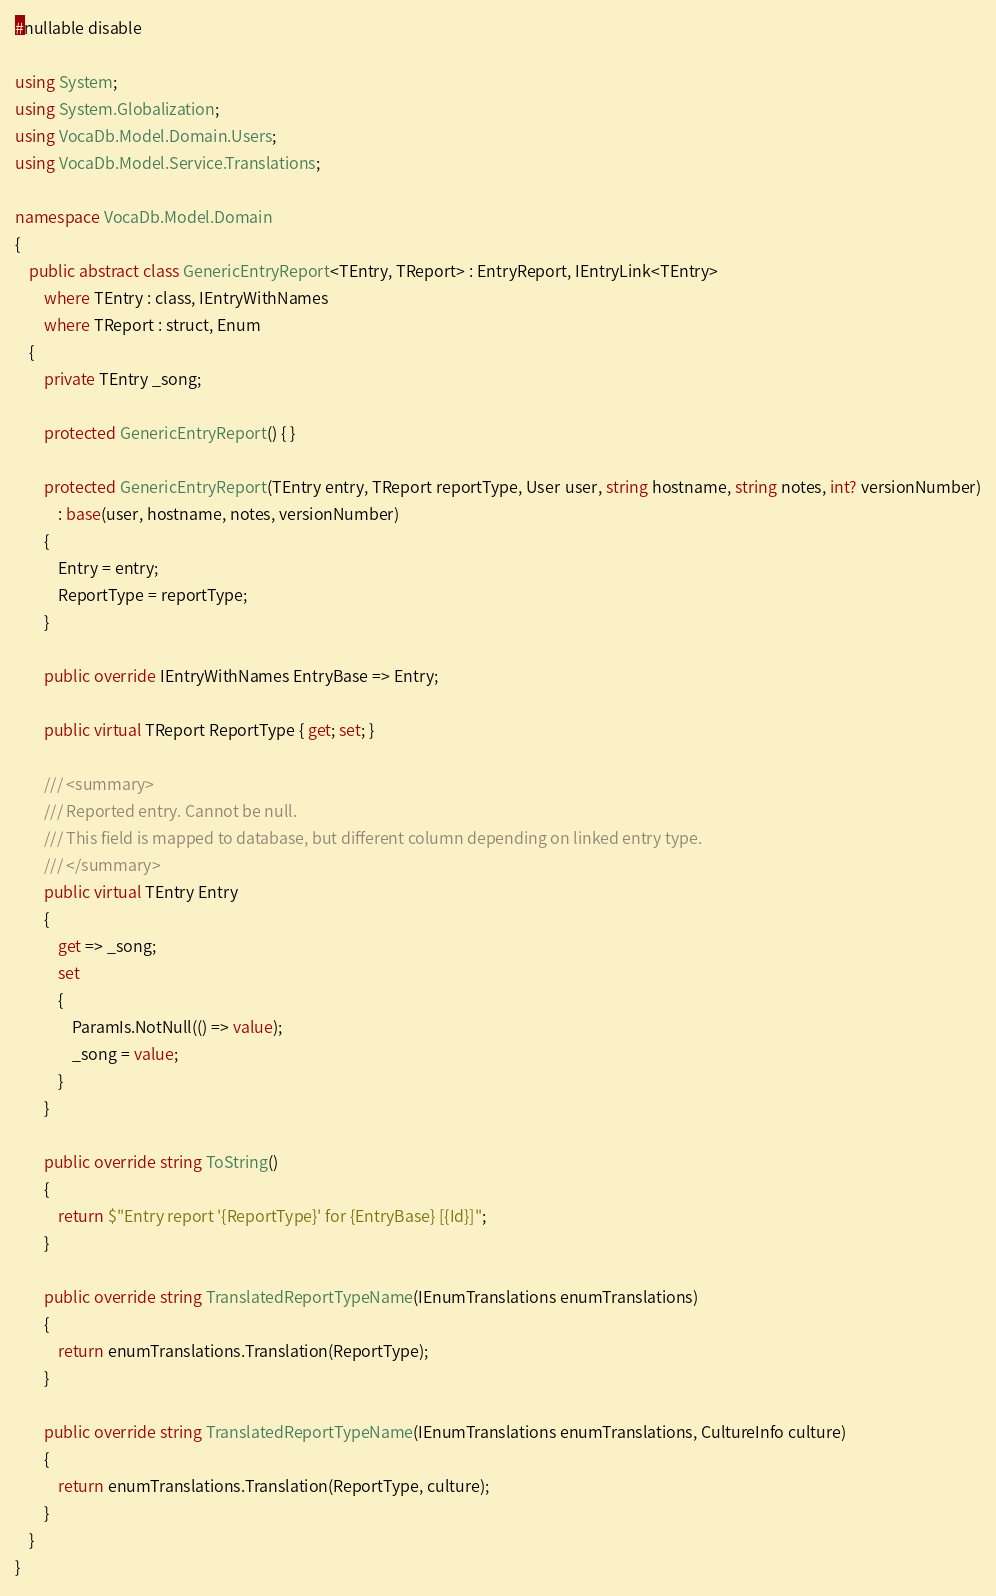Convert code to text. <code><loc_0><loc_0><loc_500><loc_500><_C#_>#nullable disable

using System;
using System.Globalization;
using VocaDb.Model.Domain.Users;
using VocaDb.Model.Service.Translations;

namespace VocaDb.Model.Domain
{
	public abstract class GenericEntryReport<TEntry, TReport> : EntryReport, IEntryLink<TEntry>
		where TEntry : class, IEntryWithNames
		where TReport : struct, Enum
	{
		private TEntry _song;

		protected GenericEntryReport() { }

		protected GenericEntryReport(TEntry entry, TReport reportType, User user, string hostname, string notes, int? versionNumber)
			: base(user, hostname, notes, versionNumber)
		{
			Entry = entry;
			ReportType = reportType;
		}

		public override IEntryWithNames EntryBase => Entry;

		public virtual TReport ReportType { get; set; }

		/// <summary>
		/// Reported entry. Cannot be null.
		/// This field is mapped to database, but different column depending on linked entry type.
		/// </summary>
		public virtual TEntry Entry
		{
			get => _song;
			set
			{
				ParamIs.NotNull(() => value);
				_song = value;
			}
		}

		public override string ToString()
		{
			return $"Entry report '{ReportType}' for {EntryBase} [{Id}]";
		}

		public override string TranslatedReportTypeName(IEnumTranslations enumTranslations)
		{
			return enumTranslations.Translation(ReportType);
		}

		public override string TranslatedReportTypeName(IEnumTranslations enumTranslations, CultureInfo culture)
		{
			return enumTranslations.Translation(ReportType, culture);
		}
	}
}
</code> 